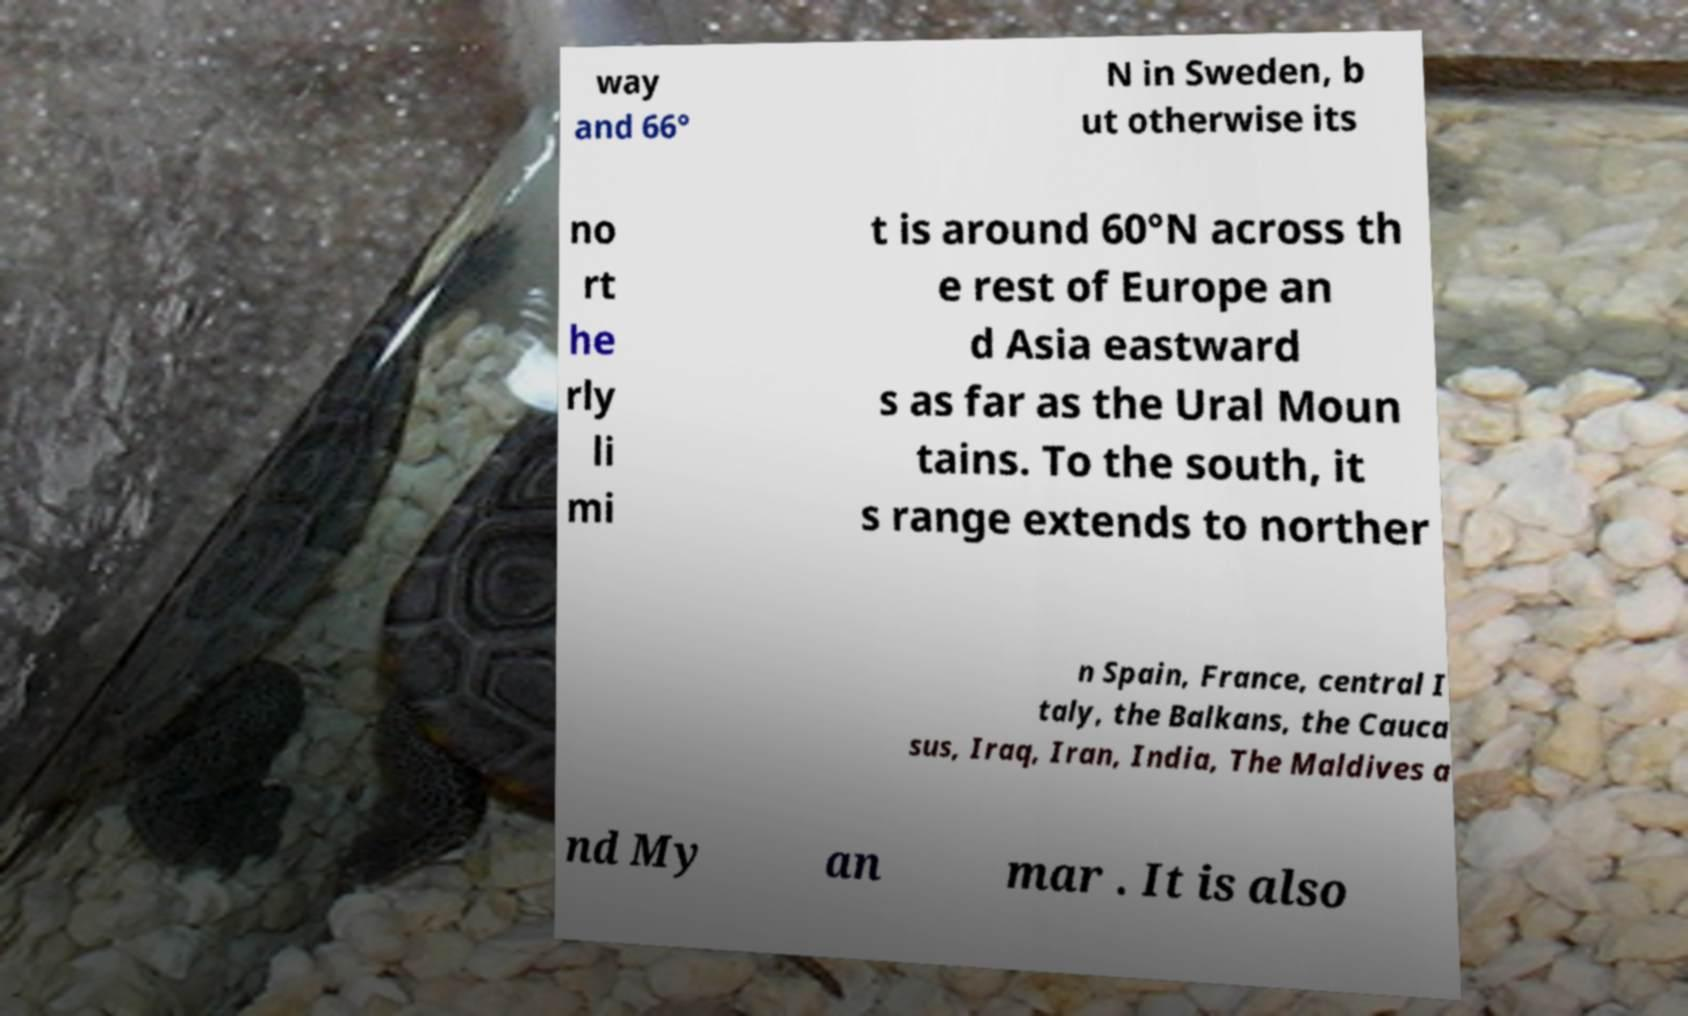Please identify and transcribe the text found in this image. way and 66° N in Sweden, b ut otherwise its no rt he rly li mi t is around 60°N across th e rest of Europe an d Asia eastward s as far as the Ural Moun tains. To the south, it s range extends to norther n Spain, France, central I taly, the Balkans, the Cauca sus, Iraq, Iran, India, The Maldives a nd My an mar . It is also 